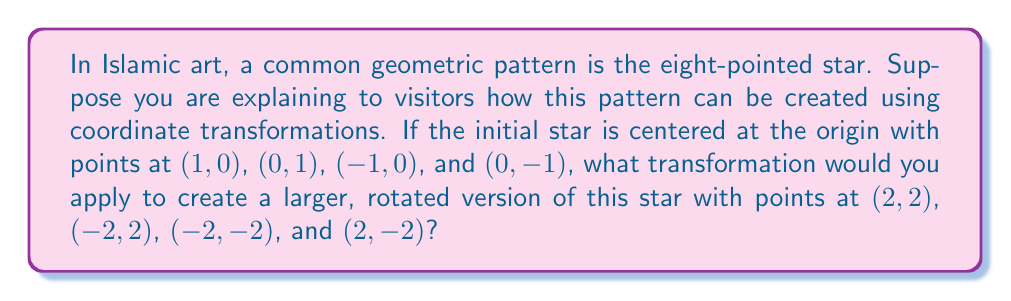Can you solve this math problem? To solve this problem, we need to apply a combination of scaling and rotation transformations:

1. Scaling:
   The original star has points at a distance of 1 from the origin, while the new star has points at a distance of $2\sqrt{2}$ from the origin. This means we need to scale by a factor of $2\sqrt{2}$.

2. Rotation:
   The original star has points along the x and y axes, while the new star has points along the lines $y=x$ and $y=-x$. This indicates a rotation of 45° (or $\frac{\pi}{4}$ radians) counterclockwise.

The transformation matrix for scaling by a factor $k$ is:
$$
\begin{pmatrix}
k & 0 \\
0 & k
\end{pmatrix}
$$

The transformation matrix for rotation by an angle $\theta$ is:
$$
\begin{pmatrix}
\cos\theta & -\sin\theta \\
\sin\theta & \cos\theta
\end{pmatrix}
$$

Combining these transformations, we get:
$$
\begin{pmatrix}
2\sqrt{2} & 0 \\
0 & 2\sqrt{2}
\end{pmatrix}
\begin{pmatrix}
\cos\frac{\pi}{4} & -\sin\frac{\pi}{4} \\
\sin\frac{\pi}{4} & \cos\frac{\pi}{4}
\end{pmatrix}
$$

Simplifying (noting that $\cos\frac{\pi}{4} = \sin\frac{\pi}{4} = \frac{1}{\sqrt{2}}$):
$$
\begin{pmatrix}
2\sqrt{2} & 0 \\
0 & 2\sqrt{2}
\end{pmatrix}
\begin{pmatrix}
\frac{1}{\sqrt{2}} & -\frac{1}{\sqrt{2}} \\
\frac{1}{\sqrt{2}} & \frac{1}{\sqrt{2}}
\end{pmatrix}
=
\begin{pmatrix}
2 & -2 \\
2 & 2
\end{pmatrix}
$$

This final matrix represents the required transformation.
Answer: The transformation matrix is $\begin{pmatrix} 2 & -2 \\ 2 & 2 \end{pmatrix}$ 